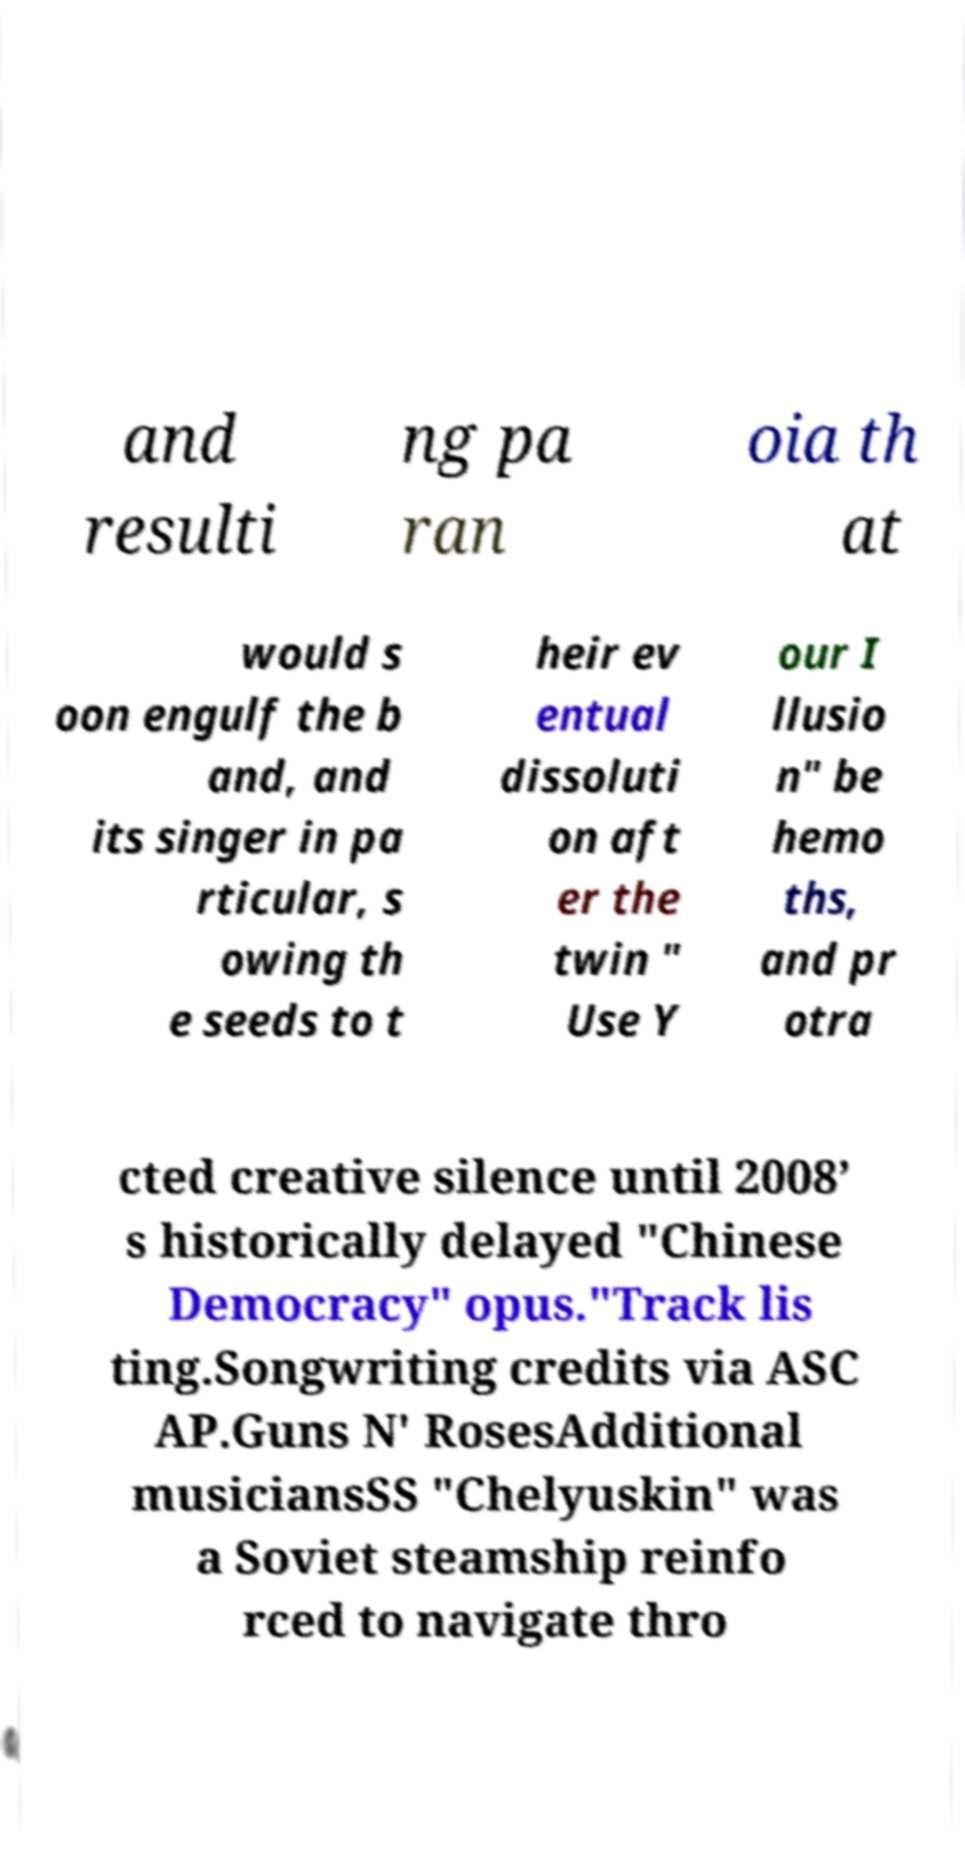Can you read and provide the text displayed in the image?This photo seems to have some interesting text. Can you extract and type it out for me? and resulti ng pa ran oia th at would s oon engulf the b and, and its singer in pa rticular, s owing th e seeds to t heir ev entual dissoluti on aft er the twin " Use Y our I llusio n" be hemo ths, and pr otra cted creative silence until 2008’ s historically delayed "Chinese Democracy" opus."Track lis ting.Songwriting credits via ASC AP.Guns N' RosesAdditional musiciansSS "Chelyuskin" was a Soviet steamship reinfo rced to navigate thro 